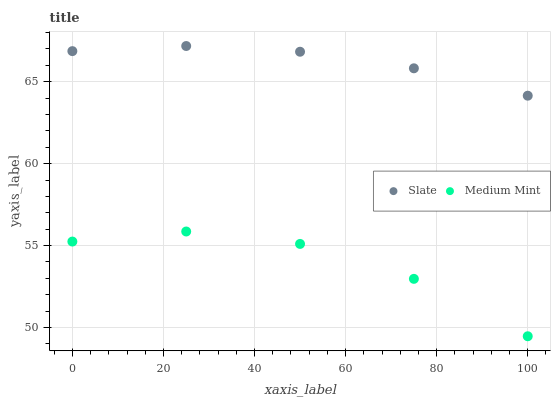Does Medium Mint have the minimum area under the curve?
Answer yes or no. Yes. Does Slate have the maximum area under the curve?
Answer yes or no. Yes. Does Slate have the minimum area under the curve?
Answer yes or no. No. Is Slate the smoothest?
Answer yes or no. Yes. Is Medium Mint the roughest?
Answer yes or no. Yes. Is Slate the roughest?
Answer yes or no. No. Does Medium Mint have the lowest value?
Answer yes or no. Yes. Does Slate have the lowest value?
Answer yes or no. No. Does Slate have the highest value?
Answer yes or no. Yes. Is Medium Mint less than Slate?
Answer yes or no. Yes. Is Slate greater than Medium Mint?
Answer yes or no. Yes. Does Medium Mint intersect Slate?
Answer yes or no. No. 